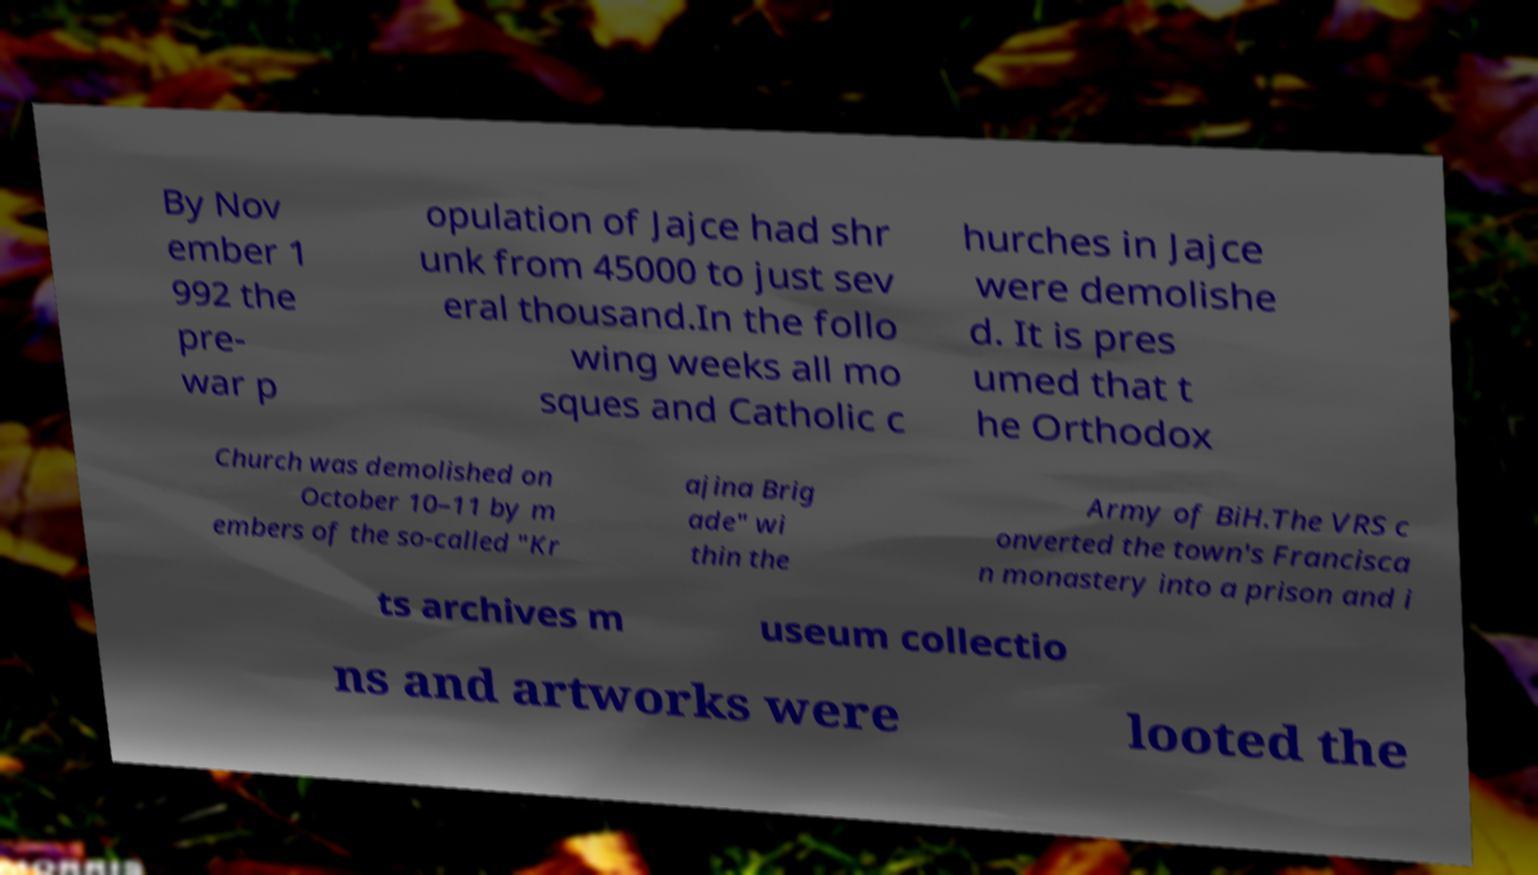For documentation purposes, I need the text within this image transcribed. Could you provide that? By Nov ember 1 992 the pre- war p opulation of Jajce had shr unk from 45000 to just sev eral thousand.In the follo wing weeks all mo sques and Catholic c hurches in Jajce were demolishe d. It is pres umed that t he Orthodox Church was demolished on October 10–11 by m embers of the so-called "Kr ajina Brig ade" wi thin the Army of BiH.The VRS c onverted the town's Francisca n monastery into a prison and i ts archives m useum collectio ns and artworks were looted the 